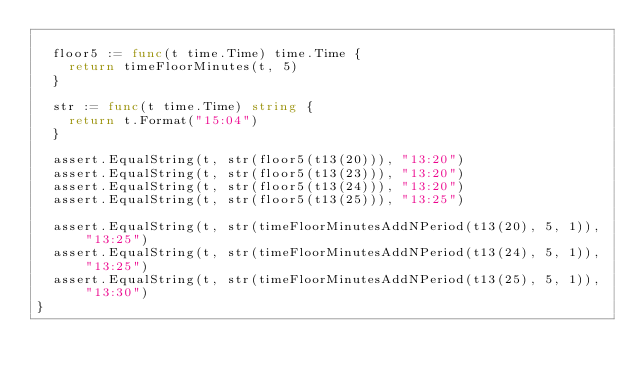<code> <loc_0><loc_0><loc_500><loc_500><_Go_>
	floor5 := func(t time.Time) time.Time {
		return timeFloorMinutes(t, 5)
	}

	str := func(t time.Time) string {
		return t.Format("15:04")
	}

	assert.EqualString(t, str(floor5(t13(20))), "13:20")
	assert.EqualString(t, str(floor5(t13(23))), "13:20")
	assert.EqualString(t, str(floor5(t13(24))), "13:20")
	assert.EqualString(t, str(floor5(t13(25))), "13:25")

	assert.EqualString(t, str(timeFloorMinutesAddNPeriod(t13(20), 5, 1)), "13:25")
	assert.EqualString(t, str(timeFloorMinutesAddNPeriod(t13(24), 5, 1)), "13:25")
	assert.EqualString(t, str(timeFloorMinutesAddNPeriod(t13(25), 5, 1)), "13:30")
}
</code> 